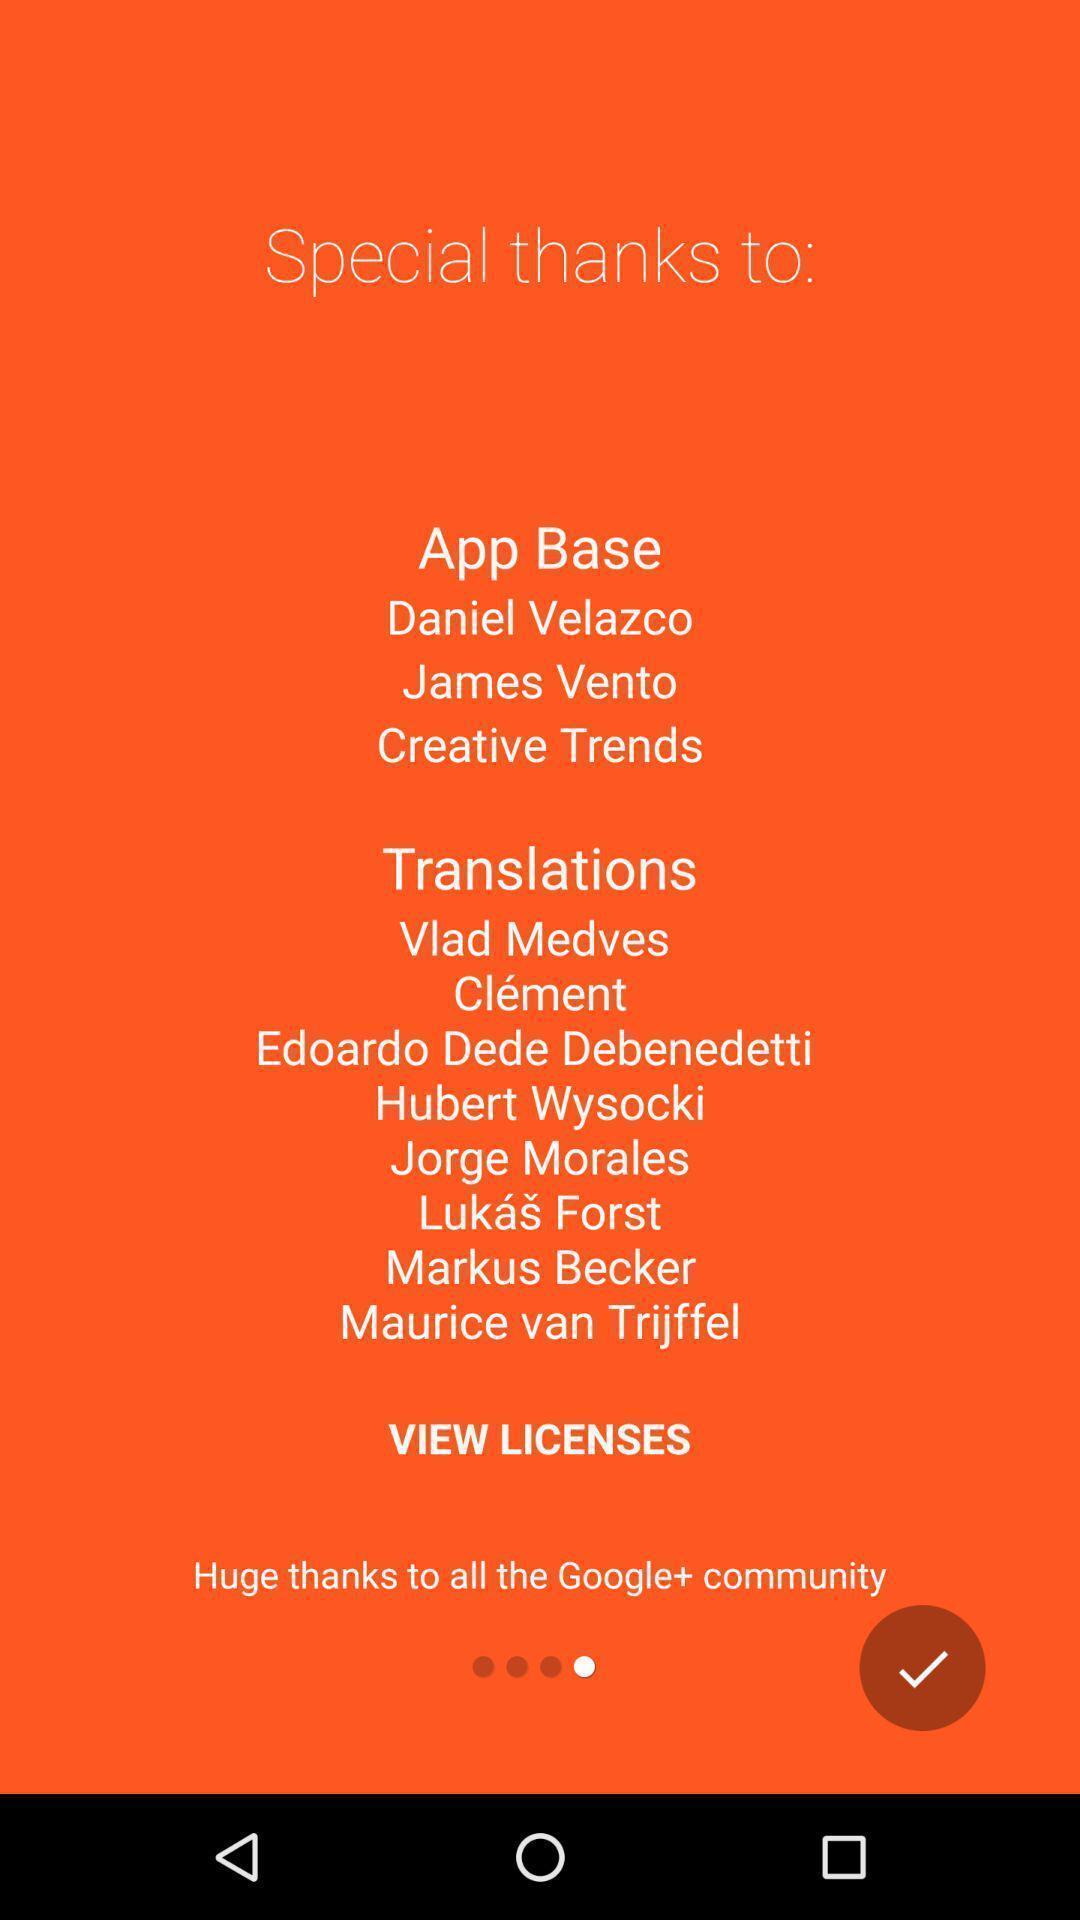Provide a detailed account of this screenshot. Screen displaying the welcome page of a learning app. 